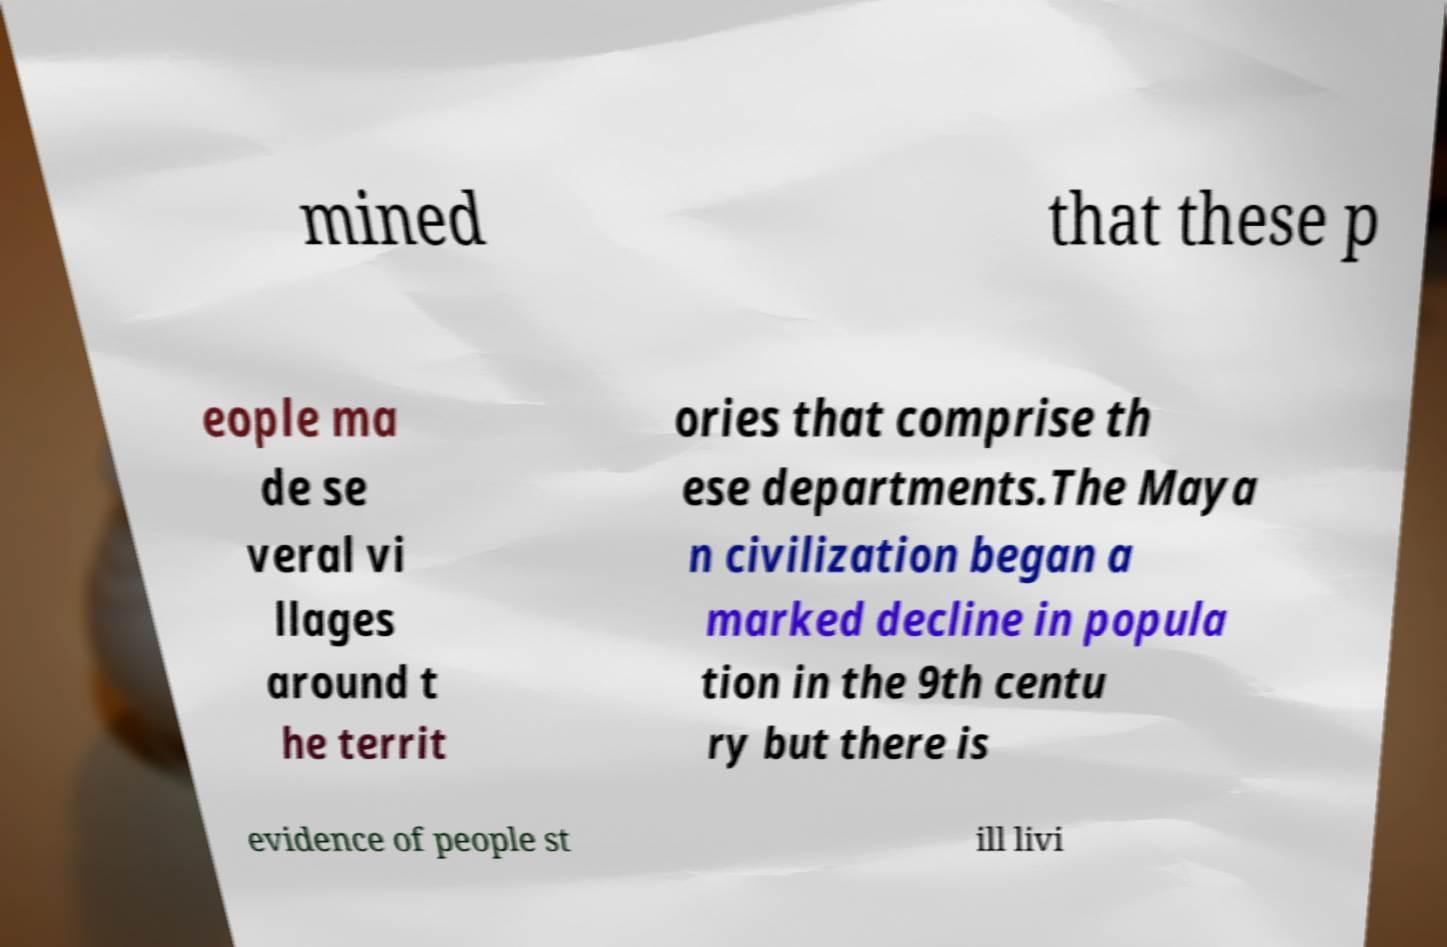Please identify and transcribe the text found in this image. mined that these p eople ma de se veral vi llages around t he territ ories that comprise th ese departments.The Maya n civilization began a marked decline in popula tion in the 9th centu ry but there is evidence of people st ill livi 